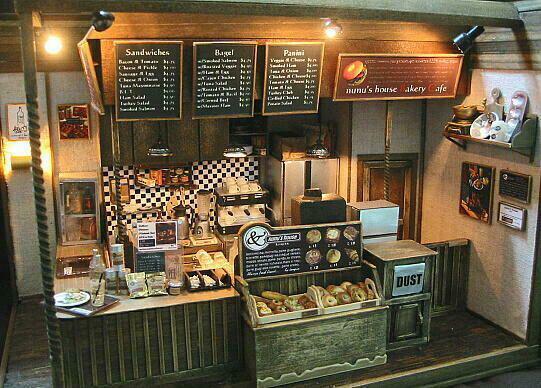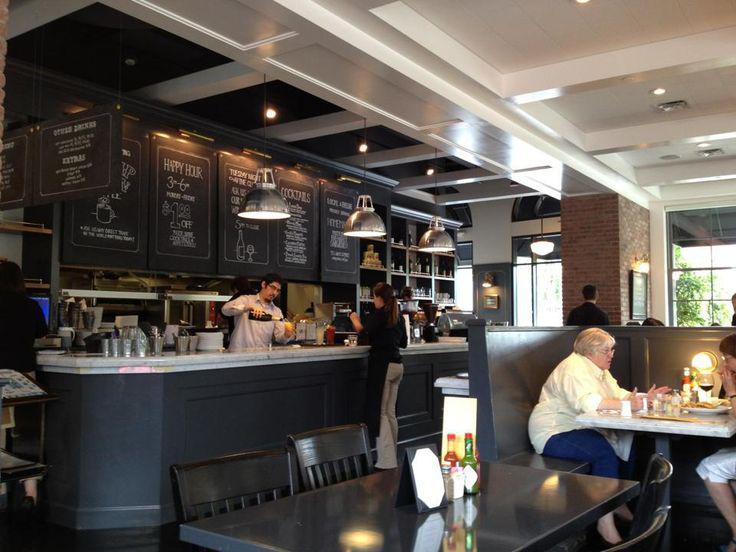The first image is the image on the left, the second image is the image on the right. Considering the images on both sides, is "In each image, a bakery cafe has its menu posted on one or more black boards, but table seating is seen in only one image." valid? Answer yes or no. Yes. The first image is the image on the left, the second image is the image on the right. Assess this claim about the two images: "At least one image shows a bakery interior with rounded tables in front of bench seats along the wall, facing display cases with blackboards hung above them.". Correct or not? Answer yes or no. No. 